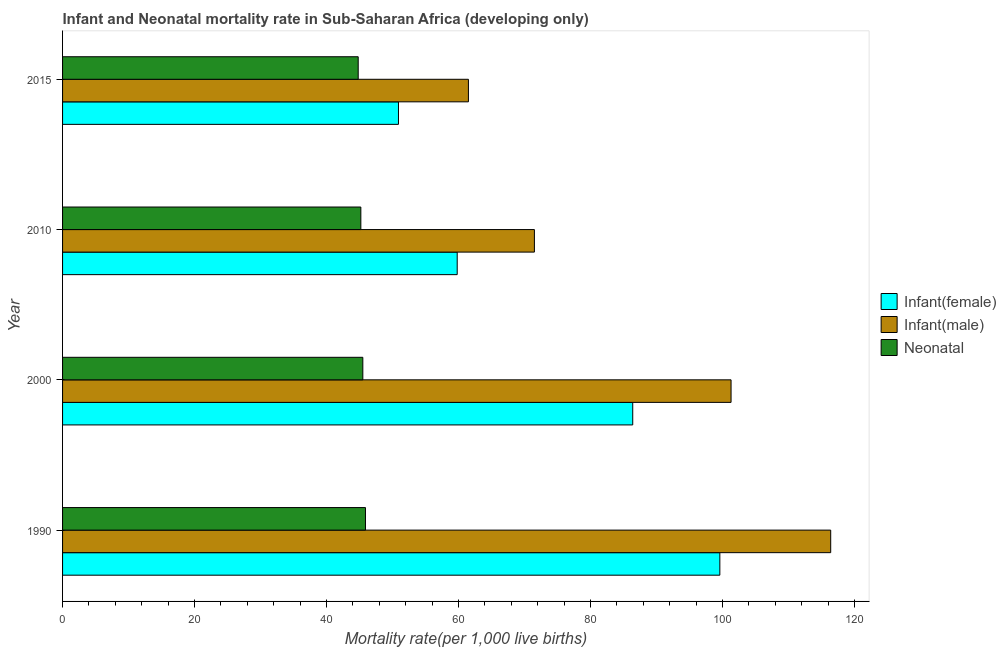How many different coloured bars are there?
Make the answer very short. 3. How many groups of bars are there?
Ensure brevity in your answer.  4. Are the number of bars per tick equal to the number of legend labels?
Ensure brevity in your answer.  Yes. How many bars are there on the 3rd tick from the bottom?
Your response must be concise. 3. What is the label of the 2nd group of bars from the top?
Your answer should be compact. 2010. In how many cases, is the number of bars for a given year not equal to the number of legend labels?
Give a very brief answer. 0. What is the neonatal mortality rate in 2015?
Keep it short and to the point. 44.8. Across all years, what is the maximum infant mortality rate(male)?
Offer a very short reply. 116.4. Across all years, what is the minimum infant mortality rate(female)?
Your answer should be very brief. 50.9. In which year was the infant mortality rate(female) maximum?
Your answer should be very brief. 1990. In which year was the infant mortality rate(female) minimum?
Ensure brevity in your answer.  2015. What is the total infant mortality rate(male) in the graph?
Make the answer very short. 350.7. What is the difference between the neonatal mortality rate in 2000 and that in 2010?
Make the answer very short. 0.3. What is the difference between the neonatal mortality rate in 2010 and the infant mortality rate(male) in 2015?
Offer a very short reply. -16.3. What is the average neonatal mortality rate per year?
Ensure brevity in your answer.  45.35. In the year 2000, what is the difference between the infant mortality rate(female) and infant mortality rate(male)?
Your answer should be very brief. -14.9. In how many years, is the infant mortality rate(female) greater than 112 ?
Your answer should be compact. 0. Is the infant mortality rate(male) in 1990 less than that in 2000?
Make the answer very short. No. Is the difference between the neonatal mortality rate in 1990 and 2010 greater than the difference between the infant mortality rate(female) in 1990 and 2010?
Ensure brevity in your answer.  No. What is the difference between the highest and the second highest infant mortality rate(female)?
Your answer should be very brief. 13.2. What is the difference between the highest and the lowest infant mortality rate(male)?
Your answer should be compact. 54.9. In how many years, is the infant mortality rate(male) greater than the average infant mortality rate(male) taken over all years?
Your response must be concise. 2. What does the 1st bar from the top in 2015 represents?
Give a very brief answer. Neonatal . What does the 3rd bar from the bottom in 1990 represents?
Give a very brief answer. Neonatal . How many bars are there?
Offer a very short reply. 12. Are all the bars in the graph horizontal?
Offer a very short reply. Yes. How many years are there in the graph?
Make the answer very short. 4. What is the difference between two consecutive major ticks on the X-axis?
Your response must be concise. 20. Does the graph contain grids?
Make the answer very short. No. How are the legend labels stacked?
Ensure brevity in your answer.  Vertical. What is the title of the graph?
Your response must be concise. Infant and Neonatal mortality rate in Sub-Saharan Africa (developing only). What is the label or title of the X-axis?
Keep it short and to the point. Mortality rate(per 1,0 live births). What is the label or title of the Y-axis?
Make the answer very short. Year. What is the Mortality rate(per 1,000 live births) in Infant(female) in 1990?
Make the answer very short. 99.6. What is the Mortality rate(per 1,000 live births) of Infant(male) in 1990?
Provide a succinct answer. 116.4. What is the Mortality rate(per 1,000 live births) of Neonatal  in 1990?
Your answer should be very brief. 45.9. What is the Mortality rate(per 1,000 live births) of Infant(female) in 2000?
Provide a short and direct response. 86.4. What is the Mortality rate(per 1,000 live births) of Infant(male) in 2000?
Your response must be concise. 101.3. What is the Mortality rate(per 1,000 live births) of Neonatal  in 2000?
Give a very brief answer. 45.5. What is the Mortality rate(per 1,000 live births) of Infant(female) in 2010?
Provide a succinct answer. 59.8. What is the Mortality rate(per 1,000 live births) in Infant(male) in 2010?
Your answer should be compact. 71.5. What is the Mortality rate(per 1,000 live births) in Neonatal  in 2010?
Offer a very short reply. 45.2. What is the Mortality rate(per 1,000 live births) of Infant(female) in 2015?
Provide a succinct answer. 50.9. What is the Mortality rate(per 1,000 live births) in Infant(male) in 2015?
Make the answer very short. 61.5. What is the Mortality rate(per 1,000 live births) in Neonatal  in 2015?
Give a very brief answer. 44.8. Across all years, what is the maximum Mortality rate(per 1,000 live births) of Infant(female)?
Your answer should be compact. 99.6. Across all years, what is the maximum Mortality rate(per 1,000 live births) in Infant(male)?
Ensure brevity in your answer.  116.4. Across all years, what is the maximum Mortality rate(per 1,000 live births) in Neonatal ?
Your answer should be compact. 45.9. Across all years, what is the minimum Mortality rate(per 1,000 live births) of Infant(female)?
Keep it short and to the point. 50.9. Across all years, what is the minimum Mortality rate(per 1,000 live births) of Infant(male)?
Your response must be concise. 61.5. Across all years, what is the minimum Mortality rate(per 1,000 live births) in Neonatal ?
Your answer should be compact. 44.8. What is the total Mortality rate(per 1,000 live births) in Infant(female) in the graph?
Provide a succinct answer. 296.7. What is the total Mortality rate(per 1,000 live births) in Infant(male) in the graph?
Keep it short and to the point. 350.7. What is the total Mortality rate(per 1,000 live births) in Neonatal  in the graph?
Offer a terse response. 181.4. What is the difference between the Mortality rate(per 1,000 live births) of Infant(female) in 1990 and that in 2000?
Ensure brevity in your answer.  13.2. What is the difference between the Mortality rate(per 1,000 live births) in Infant(male) in 1990 and that in 2000?
Keep it short and to the point. 15.1. What is the difference between the Mortality rate(per 1,000 live births) of Infant(female) in 1990 and that in 2010?
Make the answer very short. 39.8. What is the difference between the Mortality rate(per 1,000 live births) of Infant(male) in 1990 and that in 2010?
Your answer should be compact. 44.9. What is the difference between the Mortality rate(per 1,000 live births) of Neonatal  in 1990 and that in 2010?
Ensure brevity in your answer.  0.7. What is the difference between the Mortality rate(per 1,000 live births) in Infant(female) in 1990 and that in 2015?
Keep it short and to the point. 48.7. What is the difference between the Mortality rate(per 1,000 live births) in Infant(male) in 1990 and that in 2015?
Your answer should be very brief. 54.9. What is the difference between the Mortality rate(per 1,000 live births) in Neonatal  in 1990 and that in 2015?
Provide a short and direct response. 1.1. What is the difference between the Mortality rate(per 1,000 live births) in Infant(female) in 2000 and that in 2010?
Offer a very short reply. 26.6. What is the difference between the Mortality rate(per 1,000 live births) of Infant(male) in 2000 and that in 2010?
Offer a very short reply. 29.8. What is the difference between the Mortality rate(per 1,000 live births) in Neonatal  in 2000 and that in 2010?
Make the answer very short. 0.3. What is the difference between the Mortality rate(per 1,000 live births) of Infant(female) in 2000 and that in 2015?
Offer a very short reply. 35.5. What is the difference between the Mortality rate(per 1,000 live births) of Infant(male) in 2000 and that in 2015?
Give a very brief answer. 39.8. What is the difference between the Mortality rate(per 1,000 live births) in Neonatal  in 2010 and that in 2015?
Provide a succinct answer. 0.4. What is the difference between the Mortality rate(per 1,000 live births) in Infant(female) in 1990 and the Mortality rate(per 1,000 live births) in Infant(male) in 2000?
Your response must be concise. -1.7. What is the difference between the Mortality rate(per 1,000 live births) of Infant(female) in 1990 and the Mortality rate(per 1,000 live births) of Neonatal  in 2000?
Give a very brief answer. 54.1. What is the difference between the Mortality rate(per 1,000 live births) of Infant(male) in 1990 and the Mortality rate(per 1,000 live births) of Neonatal  in 2000?
Your answer should be very brief. 70.9. What is the difference between the Mortality rate(per 1,000 live births) of Infant(female) in 1990 and the Mortality rate(per 1,000 live births) of Infant(male) in 2010?
Keep it short and to the point. 28.1. What is the difference between the Mortality rate(per 1,000 live births) of Infant(female) in 1990 and the Mortality rate(per 1,000 live births) of Neonatal  in 2010?
Your response must be concise. 54.4. What is the difference between the Mortality rate(per 1,000 live births) of Infant(male) in 1990 and the Mortality rate(per 1,000 live births) of Neonatal  in 2010?
Offer a terse response. 71.2. What is the difference between the Mortality rate(per 1,000 live births) of Infant(female) in 1990 and the Mortality rate(per 1,000 live births) of Infant(male) in 2015?
Provide a succinct answer. 38.1. What is the difference between the Mortality rate(per 1,000 live births) in Infant(female) in 1990 and the Mortality rate(per 1,000 live births) in Neonatal  in 2015?
Make the answer very short. 54.8. What is the difference between the Mortality rate(per 1,000 live births) of Infant(male) in 1990 and the Mortality rate(per 1,000 live births) of Neonatal  in 2015?
Offer a very short reply. 71.6. What is the difference between the Mortality rate(per 1,000 live births) in Infant(female) in 2000 and the Mortality rate(per 1,000 live births) in Infant(male) in 2010?
Offer a terse response. 14.9. What is the difference between the Mortality rate(per 1,000 live births) in Infant(female) in 2000 and the Mortality rate(per 1,000 live births) in Neonatal  in 2010?
Your response must be concise. 41.2. What is the difference between the Mortality rate(per 1,000 live births) of Infant(male) in 2000 and the Mortality rate(per 1,000 live births) of Neonatal  in 2010?
Offer a very short reply. 56.1. What is the difference between the Mortality rate(per 1,000 live births) of Infant(female) in 2000 and the Mortality rate(per 1,000 live births) of Infant(male) in 2015?
Give a very brief answer. 24.9. What is the difference between the Mortality rate(per 1,000 live births) of Infant(female) in 2000 and the Mortality rate(per 1,000 live births) of Neonatal  in 2015?
Give a very brief answer. 41.6. What is the difference between the Mortality rate(per 1,000 live births) in Infant(male) in 2000 and the Mortality rate(per 1,000 live births) in Neonatal  in 2015?
Offer a terse response. 56.5. What is the difference between the Mortality rate(per 1,000 live births) in Infant(male) in 2010 and the Mortality rate(per 1,000 live births) in Neonatal  in 2015?
Your response must be concise. 26.7. What is the average Mortality rate(per 1,000 live births) of Infant(female) per year?
Your answer should be compact. 74.17. What is the average Mortality rate(per 1,000 live births) of Infant(male) per year?
Your answer should be very brief. 87.67. What is the average Mortality rate(per 1,000 live births) of Neonatal  per year?
Your response must be concise. 45.35. In the year 1990, what is the difference between the Mortality rate(per 1,000 live births) in Infant(female) and Mortality rate(per 1,000 live births) in Infant(male)?
Your response must be concise. -16.8. In the year 1990, what is the difference between the Mortality rate(per 1,000 live births) of Infant(female) and Mortality rate(per 1,000 live births) of Neonatal ?
Offer a terse response. 53.7. In the year 1990, what is the difference between the Mortality rate(per 1,000 live births) of Infant(male) and Mortality rate(per 1,000 live births) of Neonatal ?
Your answer should be very brief. 70.5. In the year 2000, what is the difference between the Mortality rate(per 1,000 live births) of Infant(female) and Mortality rate(per 1,000 live births) of Infant(male)?
Make the answer very short. -14.9. In the year 2000, what is the difference between the Mortality rate(per 1,000 live births) in Infant(female) and Mortality rate(per 1,000 live births) in Neonatal ?
Make the answer very short. 40.9. In the year 2000, what is the difference between the Mortality rate(per 1,000 live births) in Infant(male) and Mortality rate(per 1,000 live births) in Neonatal ?
Provide a short and direct response. 55.8. In the year 2010, what is the difference between the Mortality rate(per 1,000 live births) of Infant(female) and Mortality rate(per 1,000 live births) of Infant(male)?
Your answer should be very brief. -11.7. In the year 2010, what is the difference between the Mortality rate(per 1,000 live births) in Infant(female) and Mortality rate(per 1,000 live births) in Neonatal ?
Provide a short and direct response. 14.6. In the year 2010, what is the difference between the Mortality rate(per 1,000 live births) of Infant(male) and Mortality rate(per 1,000 live births) of Neonatal ?
Give a very brief answer. 26.3. In the year 2015, what is the difference between the Mortality rate(per 1,000 live births) in Infant(female) and Mortality rate(per 1,000 live births) in Neonatal ?
Your response must be concise. 6.1. In the year 2015, what is the difference between the Mortality rate(per 1,000 live births) in Infant(male) and Mortality rate(per 1,000 live births) in Neonatal ?
Your answer should be compact. 16.7. What is the ratio of the Mortality rate(per 1,000 live births) of Infant(female) in 1990 to that in 2000?
Provide a short and direct response. 1.15. What is the ratio of the Mortality rate(per 1,000 live births) of Infant(male) in 1990 to that in 2000?
Offer a terse response. 1.15. What is the ratio of the Mortality rate(per 1,000 live births) of Neonatal  in 1990 to that in 2000?
Keep it short and to the point. 1.01. What is the ratio of the Mortality rate(per 1,000 live births) of Infant(female) in 1990 to that in 2010?
Offer a very short reply. 1.67. What is the ratio of the Mortality rate(per 1,000 live births) of Infant(male) in 1990 to that in 2010?
Make the answer very short. 1.63. What is the ratio of the Mortality rate(per 1,000 live births) in Neonatal  in 1990 to that in 2010?
Provide a succinct answer. 1.02. What is the ratio of the Mortality rate(per 1,000 live births) of Infant(female) in 1990 to that in 2015?
Give a very brief answer. 1.96. What is the ratio of the Mortality rate(per 1,000 live births) in Infant(male) in 1990 to that in 2015?
Ensure brevity in your answer.  1.89. What is the ratio of the Mortality rate(per 1,000 live births) in Neonatal  in 1990 to that in 2015?
Provide a succinct answer. 1.02. What is the ratio of the Mortality rate(per 1,000 live births) in Infant(female) in 2000 to that in 2010?
Your answer should be compact. 1.44. What is the ratio of the Mortality rate(per 1,000 live births) of Infant(male) in 2000 to that in 2010?
Provide a short and direct response. 1.42. What is the ratio of the Mortality rate(per 1,000 live births) in Neonatal  in 2000 to that in 2010?
Make the answer very short. 1.01. What is the ratio of the Mortality rate(per 1,000 live births) of Infant(female) in 2000 to that in 2015?
Ensure brevity in your answer.  1.7. What is the ratio of the Mortality rate(per 1,000 live births) in Infant(male) in 2000 to that in 2015?
Give a very brief answer. 1.65. What is the ratio of the Mortality rate(per 1,000 live births) of Neonatal  in 2000 to that in 2015?
Ensure brevity in your answer.  1.02. What is the ratio of the Mortality rate(per 1,000 live births) in Infant(female) in 2010 to that in 2015?
Make the answer very short. 1.17. What is the ratio of the Mortality rate(per 1,000 live births) of Infant(male) in 2010 to that in 2015?
Provide a succinct answer. 1.16. What is the ratio of the Mortality rate(per 1,000 live births) of Neonatal  in 2010 to that in 2015?
Provide a short and direct response. 1.01. What is the difference between the highest and the second highest Mortality rate(per 1,000 live births) of Infant(female)?
Your answer should be very brief. 13.2. What is the difference between the highest and the lowest Mortality rate(per 1,000 live births) of Infant(female)?
Provide a succinct answer. 48.7. What is the difference between the highest and the lowest Mortality rate(per 1,000 live births) of Infant(male)?
Give a very brief answer. 54.9. What is the difference between the highest and the lowest Mortality rate(per 1,000 live births) in Neonatal ?
Provide a succinct answer. 1.1. 